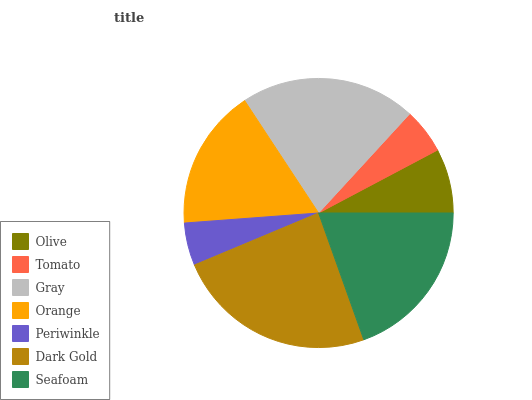Is Periwinkle the minimum?
Answer yes or no. Yes. Is Dark Gold the maximum?
Answer yes or no. Yes. Is Tomato the minimum?
Answer yes or no. No. Is Tomato the maximum?
Answer yes or no. No. Is Olive greater than Tomato?
Answer yes or no. Yes. Is Tomato less than Olive?
Answer yes or no. Yes. Is Tomato greater than Olive?
Answer yes or no. No. Is Olive less than Tomato?
Answer yes or no. No. Is Orange the high median?
Answer yes or no. Yes. Is Orange the low median?
Answer yes or no. Yes. Is Dark Gold the high median?
Answer yes or no. No. Is Olive the low median?
Answer yes or no. No. 